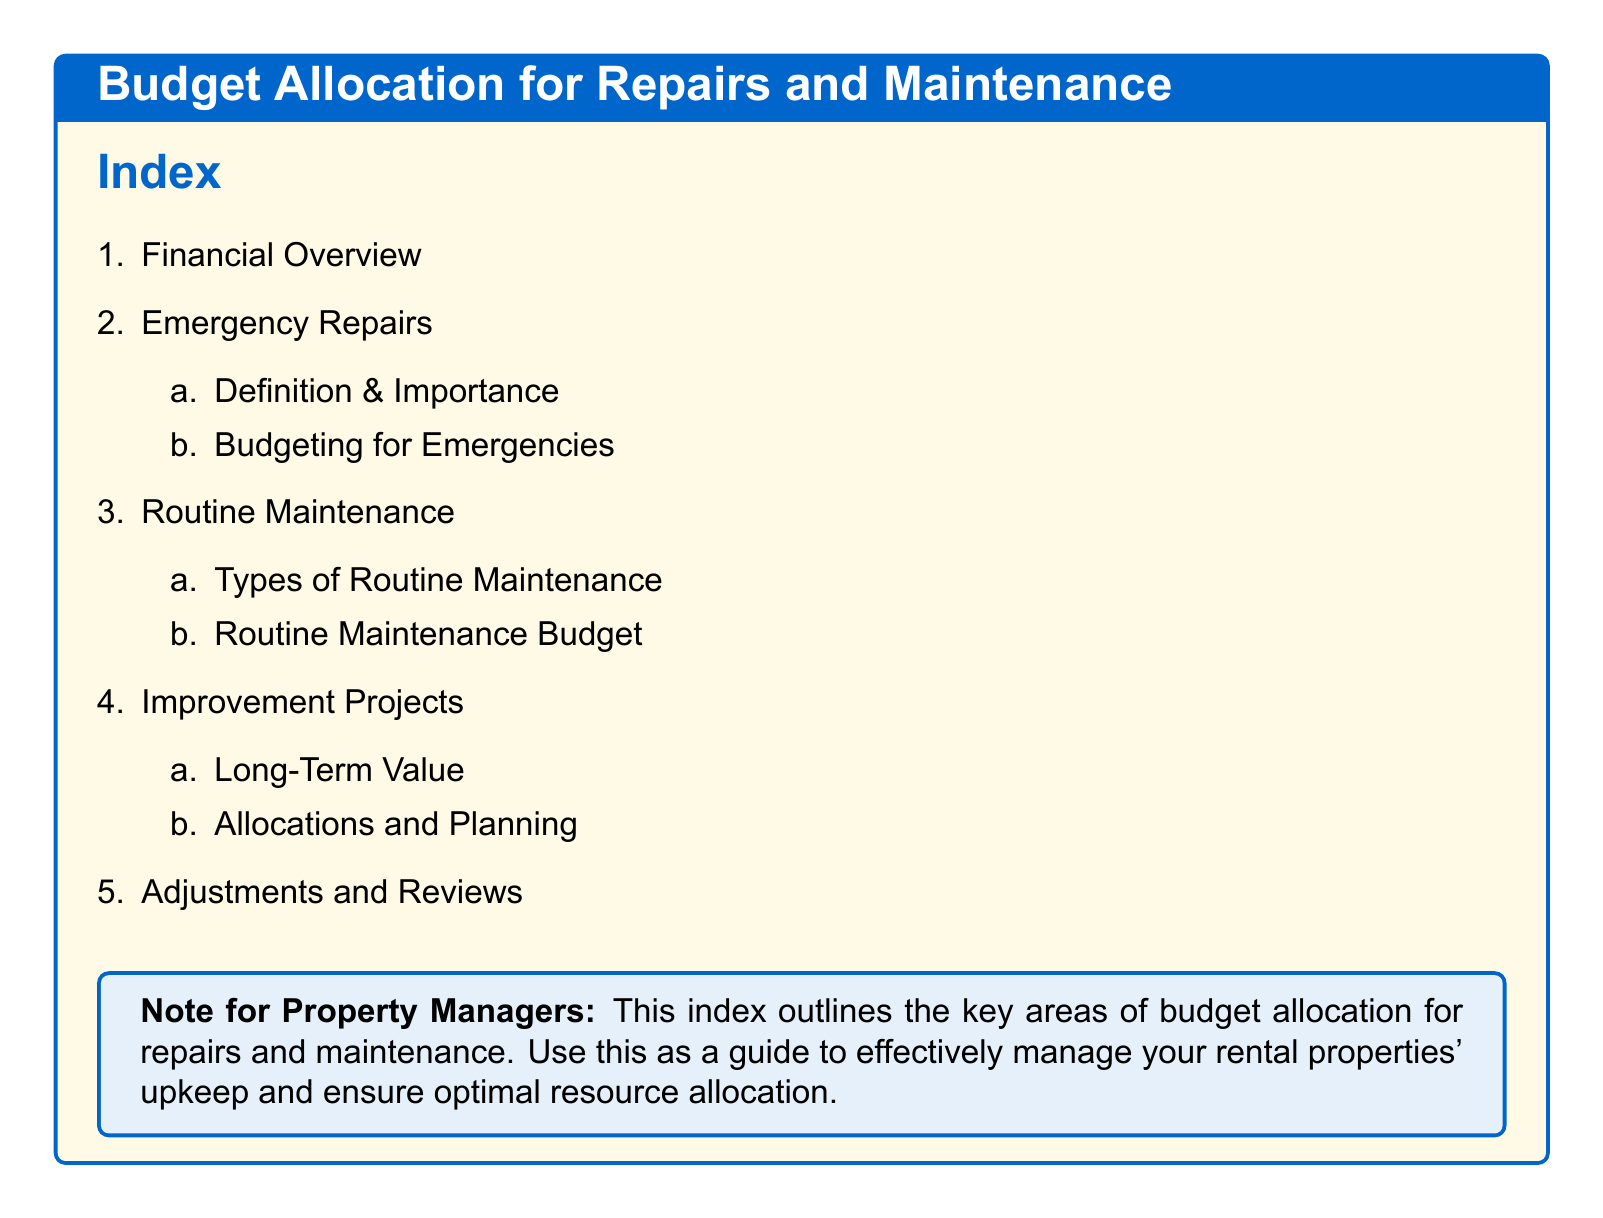what is the title of the document? The title of the document is prominently displayed in the tcolorbox at the beginning.
Answer: Budget Allocation for Repairs and Maintenance how many main sections are in the index? The main sections listed in the index provide an overview of the document content.
Answer: 5 what is included under emergency repairs? Emergency repairs are further elaborated into two subtopics in the index for understanding.
Answer: Definition & Importance, Budgeting for Emergencies what is the focus of routine maintenance? The index indicates that routine maintenance has two specific aspects that need to be considered.
Answer: Types of Routine Maintenance, Routine Maintenance Budget which section discusses long-term value? The section that addresses long-term value is specific to the nature of improvement projects.
Answer: Improvement Projects what is the purpose of the note for property managers? The note provides guidance to property managers on how to utilize the information in the index effectively.
Answer: To manage rental properties' upkeep and ensure optimal resource allocation 